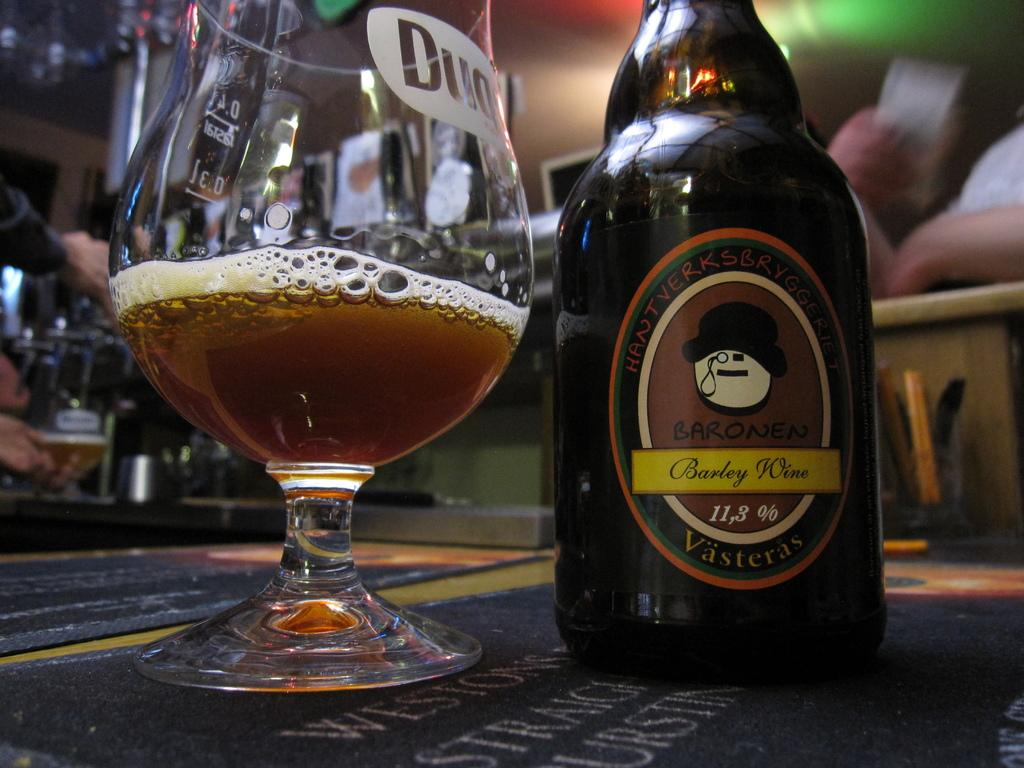<image>
Render a clear and concise summary of the photo. a glass and bottle of Barley Wine with 11.3% alcohol 